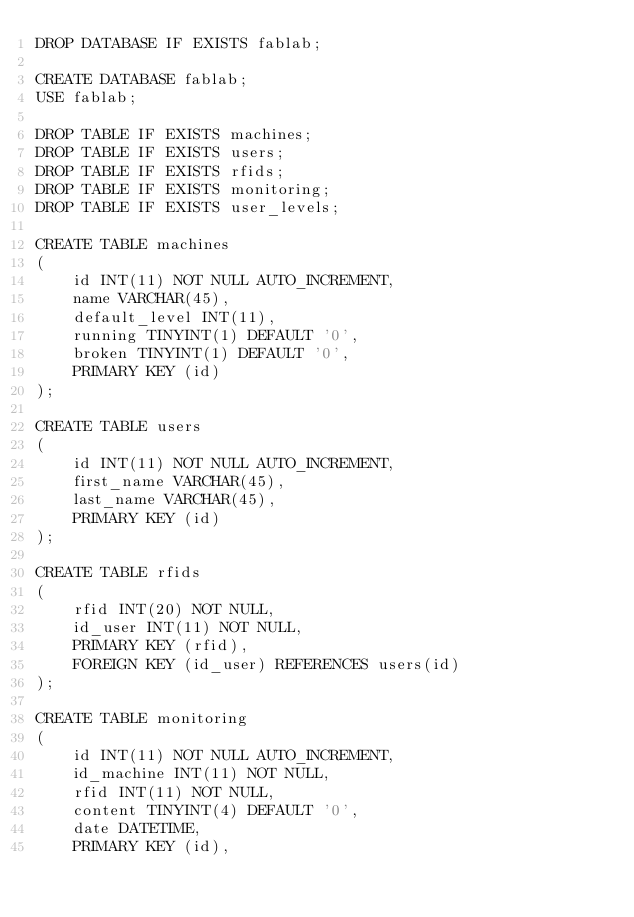<code> <loc_0><loc_0><loc_500><loc_500><_SQL_>DROP DATABASE IF EXISTS fablab;

CREATE DATABASE fablab;
USE fablab;

DROP TABLE IF EXISTS machines;
DROP TABLE IF EXISTS users;
DROP TABLE IF EXISTS rfids;
DROP TABLE IF EXISTS monitoring;
DROP TABLE IF EXISTS user_levels;

CREATE TABLE machines 
(
    id INT(11) NOT NULL AUTO_INCREMENT,
    name VARCHAR(45),
    default_level INT(11),
	running TINYINT(1) DEFAULT '0',
	broken TINYINT(1) DEFAULT '0',
    PRIMARY KEY (id)
);

CREATE TABLE users
(
    id INT(11) NOT NULL AUTO_INCREMENT,
    first_name VARCHAR(45),
    last_name VARCHAR(45),
    PRIMARY KEY (id)
);

CREATE TABLE rfids
(
    rfid INT(20) NOT NULL,
    id_user INT(11) NOT NULL,
    PRIMARY KEY (rfid),
    FOREIGN KEY (id_user) REFERENCES users(id)
);

CREATE TABLE monitoring 
(
    id INT(11) NOT NULL AUTO_INCREMENT,
    id_machine INT(11) NOT NULL,
    rfid INT(11) NOT NULL,
    content TINYINT(4) DEFAULT '0',
    date DATETIME,
    PRIMARY KEY (id),</code> 